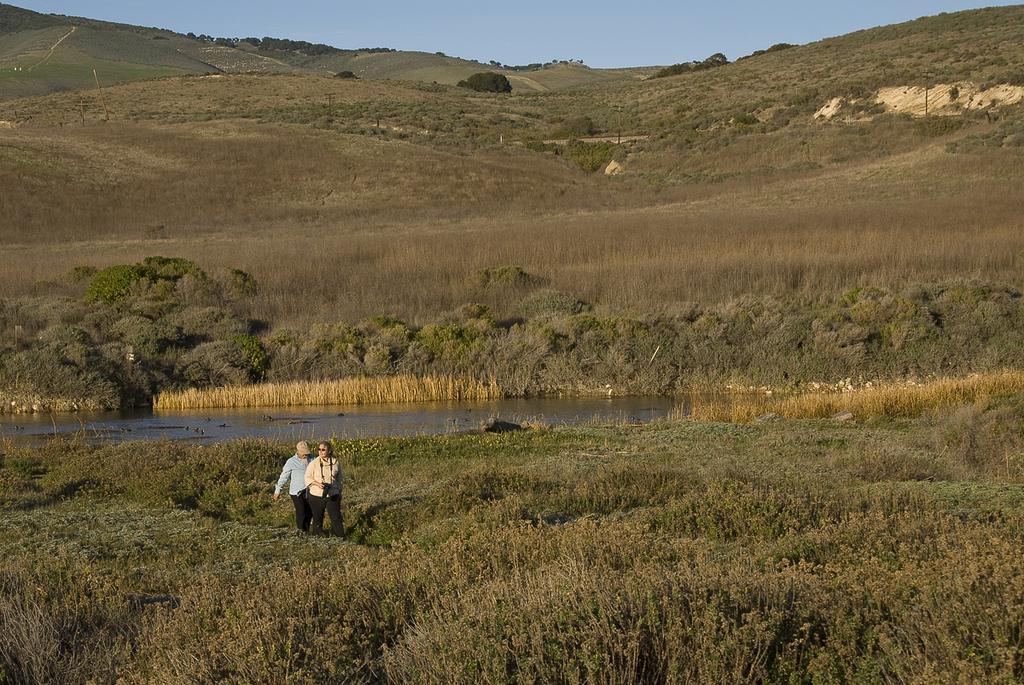Can you describe this image briefly? In this image I can see two people standing on the ground. These people are wearing the different color dresses and one person with the cap. To the back of these people I can see the water and the trees. In the background there is a mountain and the blue sky. 